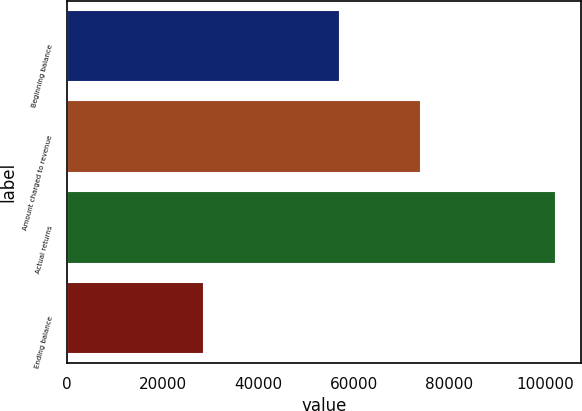Convert chart. <chart><loc_0><loc_0><loc_500><loc_500><bar_chart><fcel>Beginning balance<fcel>Amount charged to revenue<fcel>Actual returns<fcel>Ending balance<nl><fcel>57058<fcel>74031<fcel>102425<fcel>28664<nl></chart> 